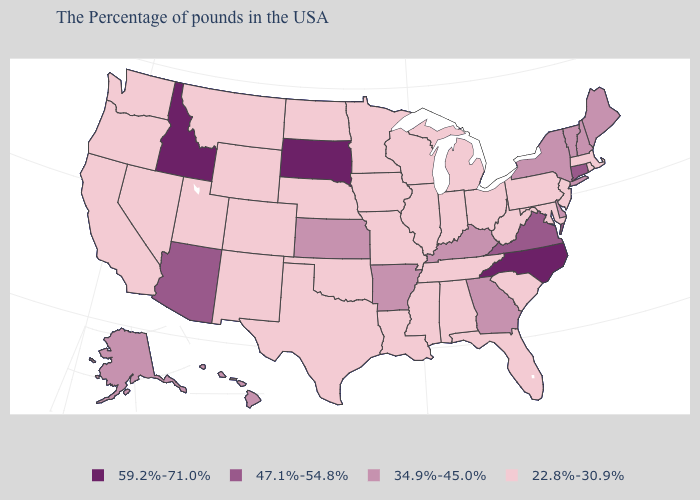Does Maryland have the lowest value in the USA?
Write a very short answer. Yes. Does Montana have the same value as Mississippi?
Concise answer only. Yes. Name the states that have a value in the range 47.1%-54.8%?
Quick response, please. Connecticut, Virginia, Arizona. What is the value of South Dakota?
Be succinct. 59.2%-71.0%. What is the lowest value in the USA?
Write a very short answer. 22.8%-30.9%. What is the value of Illinois?
Answer briefly. 22.8%-30.9%. Does the map have missing data?
Give a very brief answer. No. Name the states that have a value in the range 34.9%-45.0%?
Short answer required. Maine, New Hampshire, Vermont, New York, Delaware, Georgia, Kentucky, Arkansas, Kansas, Alaska, Hawaii. Name the states that have a value in the range 59.2%-71.0%?
Give a very brief answer. North Carolina, South Dakota, Idaho. Does New York have the same value as New Hampshire?
Answer briefly. Yes. Among the states that border Texas , which have the highest value?
Write a very short answer. Arkansas. Does Idaho have the same value as South Dakota?
Give a very brief answer. Yes. Does Utah have a lower value than Maryland?
Keep it brief. No. What is the value of Minnesota?
Be succinct. 22.8%-30.9%. 